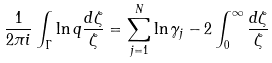<formula> <loc_0><loc_0><loc_500><loc_500>\frac { 1 } { 2 \pi i } \int _ { \Gamma } \ln q \frac { d \zeta } { \zeta } = \sum _ { j = 1 } ^ { N } \ln \gamma _ { j } - 2 \int _ { 0 } ^ { \infty } \frac { d \zeta } { \zeta }</formula> 